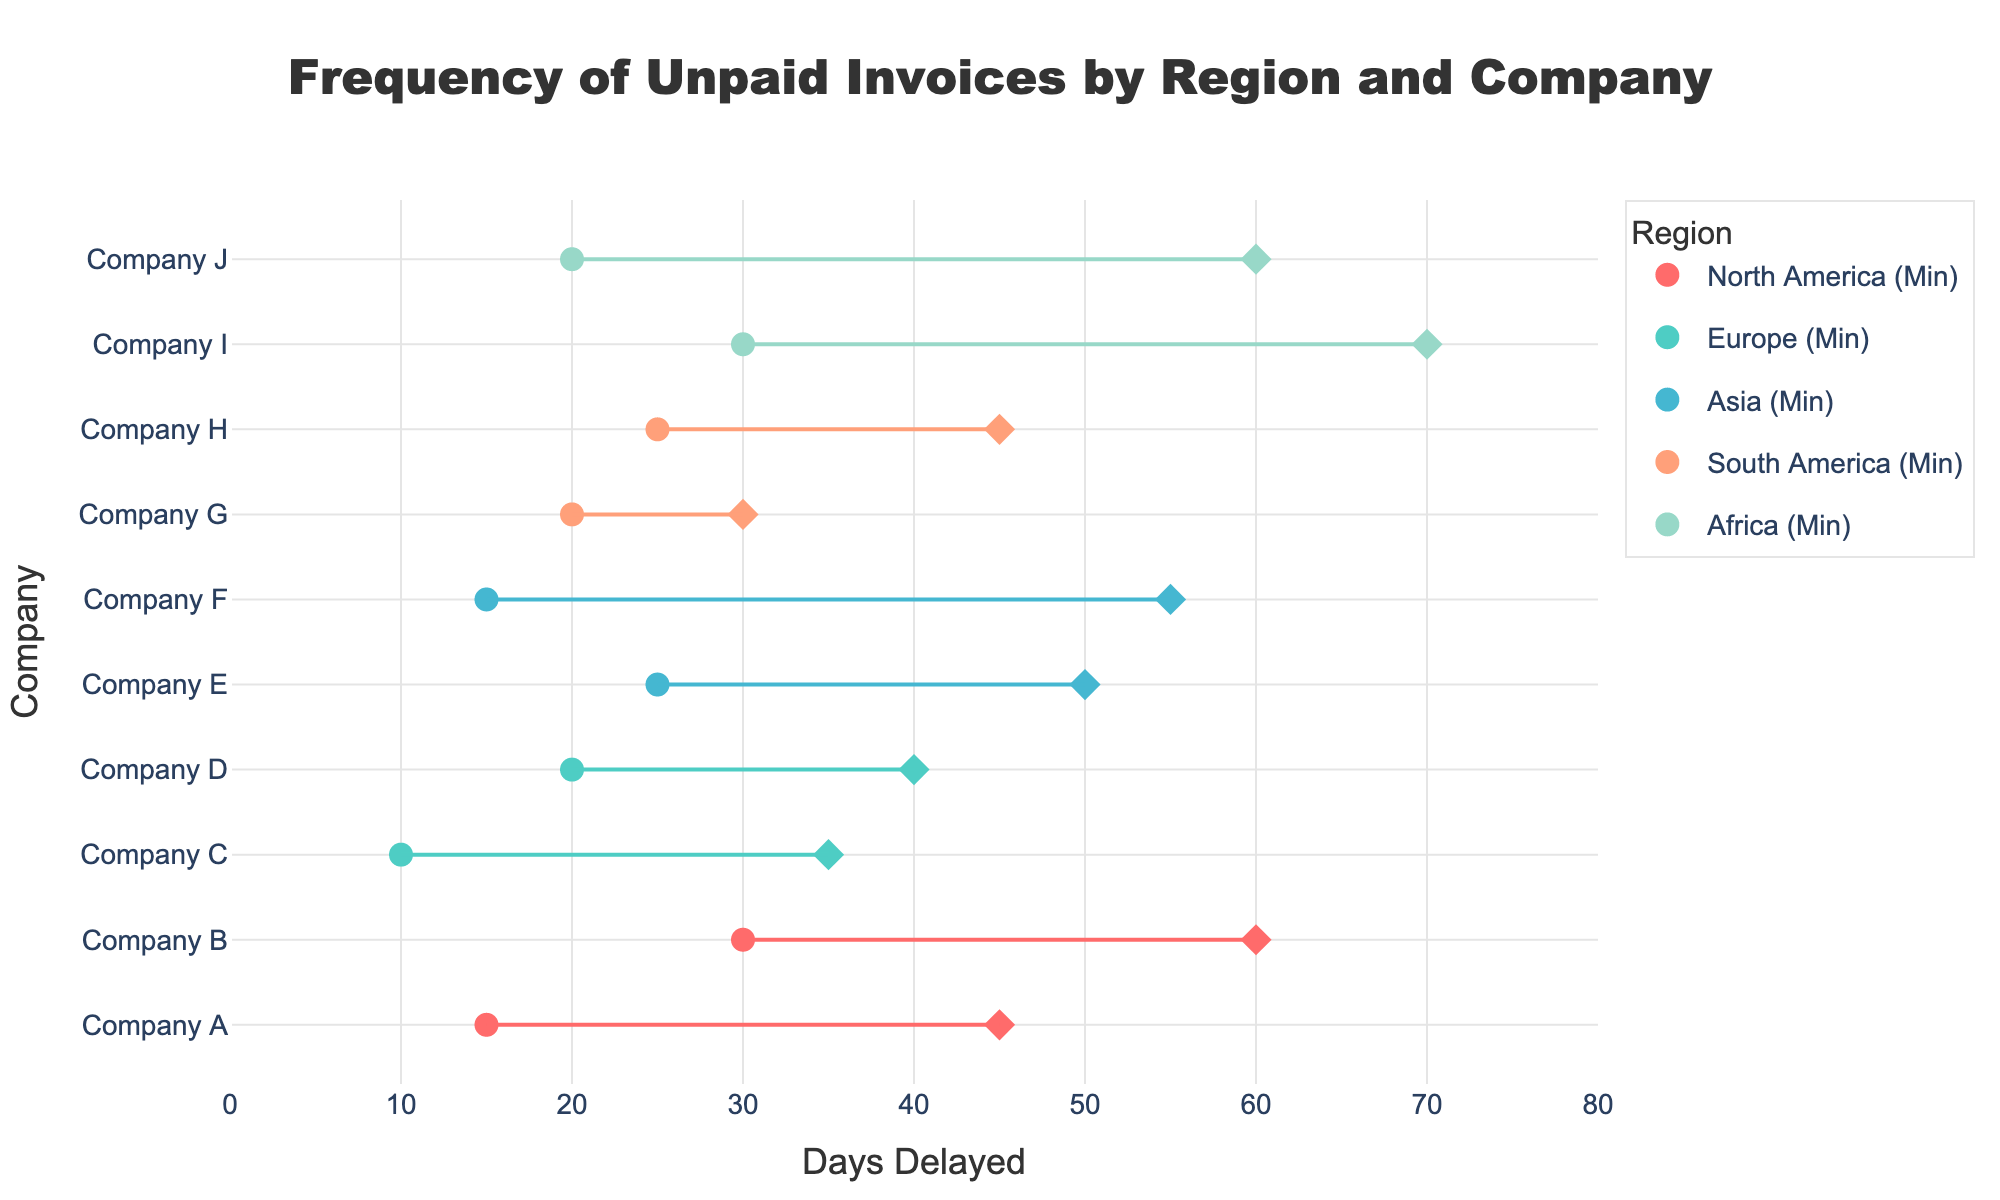What's the title of the figure? The title is located at the top center of the figure and reads: "Frequency of Unpaid Invoices by Region and Company".
Answer: Frequency of Unpaid Invoices by Region and Company Which company in North America has the longest maximum delay for unpaid invoices? In North America, Company B has the longest maximum delay, which is represented by the diamond marker for maximum delay, and it reaches up to 60 days as per the x-axis.
Answer: Company B What is the range of days delayed for unpaid invoices reported by Company J in Africa? The range is the difference between the maximum and minimum delays for Company J. From the plot, the minimum delay for Company J is 20 days, and the maximum delay is 60 days. So, the range is 60 - 20 = 40 days.
Answer: 40 days Which region shows the highest variance in days delayed for unpaid invoices across companies? To determine the highest variance, observe the spread between the minimum and maximum delay markers (circle to diamond) for each region. Africa shows the widest spread as companies have ranges spanning from 20 to 70 days.
Answer: Africa How many companies' unpaid invoices have a minimum delay of 20 days? Look for circular markers on the 20-day tick on the x-axis. In the plot, Company D in Europe, Company G in South America, and Company J in Africa have minimum delays of 20 days. So, there are three companies.
Answer: 3 companies Which company in Asia has the smallest maximum days delayed for unpaid invoices? In Asia, compare the diamond markers representing the maximum delays. Company E has the smallest maximum delay at 50 days.
Answer: Company E What is the average maximum delay for companies in South America? The companies in South America are Company G with 30 days and Company H with 45 days. The average is calculated as (30 + 45) / 2 = 75 / 2 = 37.5 days.
Answer: 37.5 days What’s the minimum and maximum days delayed for the company with the shortest minimum delay in Europe? Identify the company in Europe with the shortest minimum delay, which is Company C at 10 days. The maximum delay for Company C is 35 days, as indicated by the diamond marker.
Answer: 10 and 35 days Are there any companies where the range of days delayed is the same? Compare the ranges of delays for all companies. Company D (20-40 days) and Company H (25-45 days) both have a range of 20 days, so they have the same delay range.
Answer: Yes 